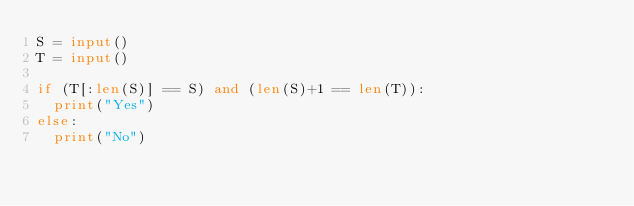<code> <loc_0><loc_0><loc_500><loc_500><_Python_>S = input()
T = input()

if (T[:len(S)] == S) and (len(S)+1 == len(T)):
  print("Yes")
else:
  print("No")
</code> 